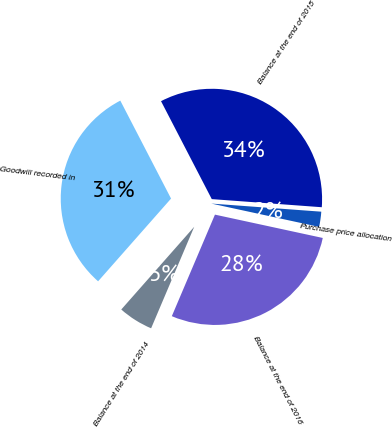Convert chart. <chart><loc_0><loc_0><loc_500><loc_500><pie_chart><fcel>Balance at the end of 2014<fcel>Goodwill recorded in<fcel>Balance at the end of 2015<fcel>Purchase price allocation<fcel>Balance at the end of 2016<nl><fcel>5.11%<fcel>30.89%<fcel>33.78%<fcel>2.22%<fcel>28.0%<nl></chart> 